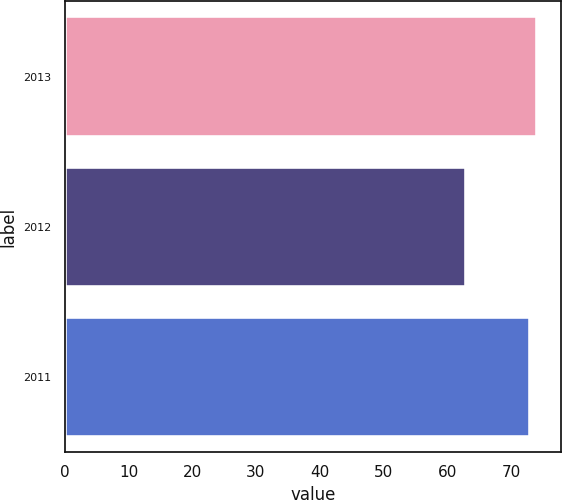<chart> <loc_0><loc_0><loc_500><loc_500><bar_chart><fcel>2013<fcel>2012<fcel>2011<nl><fcel>74.1<fcel>63<fcel>73<nl></chart> 